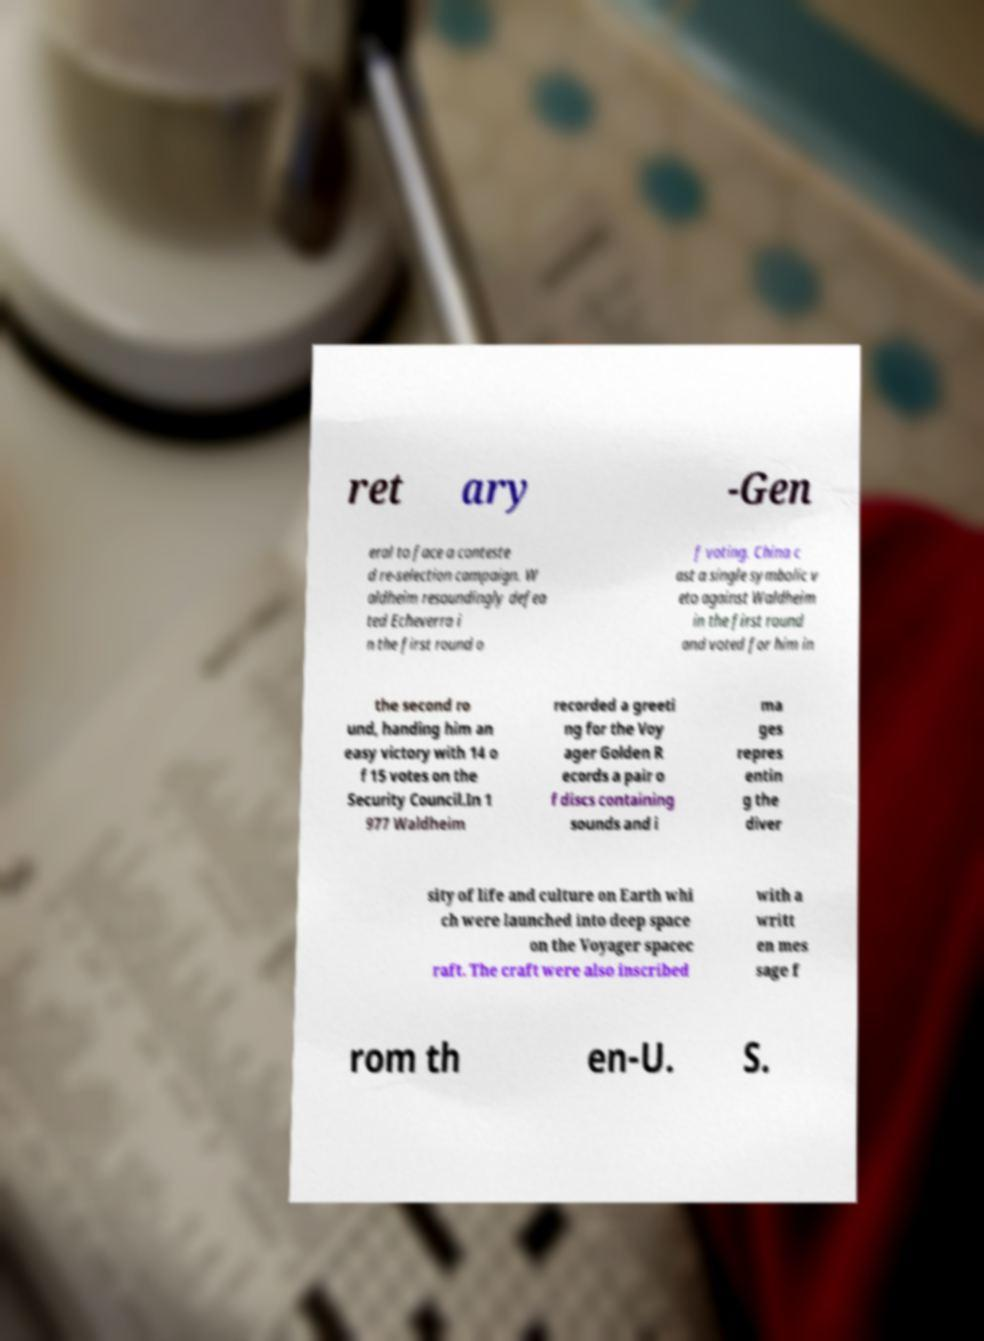What messages or text are displayed in this image? I need them in a readable, typed format. ret ary -Gen eral to face a conteste d re-selection campaign. W aldheim resoundingly defea ted Echeverra i n the first round o f voting. China c ast a single symbolic v eto against Waldheim in the first round and voted for him in the second ro und, handing him an easy victory with 14 o f 15 votes on the Security Council.In 1 977 Waldheim recorded a greeti ng for the Voy ager Golden R ecords a pair o f discs containing sounds and i ma ges repres entin g the diver sity of life and culture on Earth whi ch were launched into deep space on the Voyager spacec raft. The craft were also inscribed with a writt en mes sage f rom th en-U. S. 